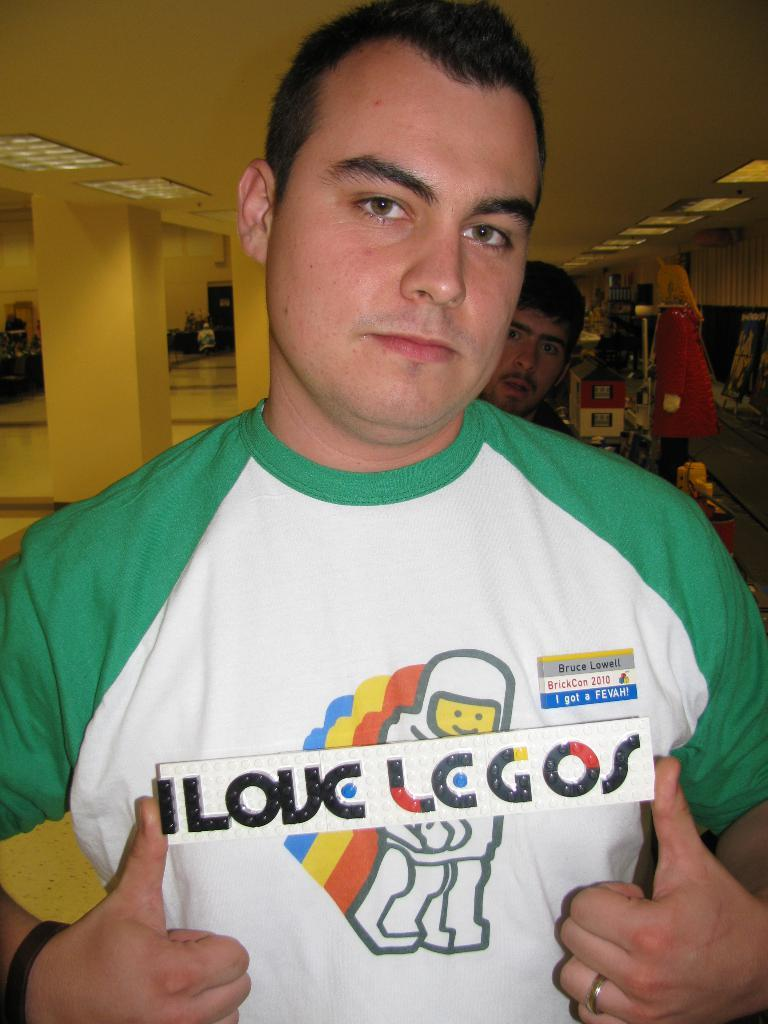Provide a one-sentence caption for the provided image. A man has a name tag on designating his name as Bruce. 